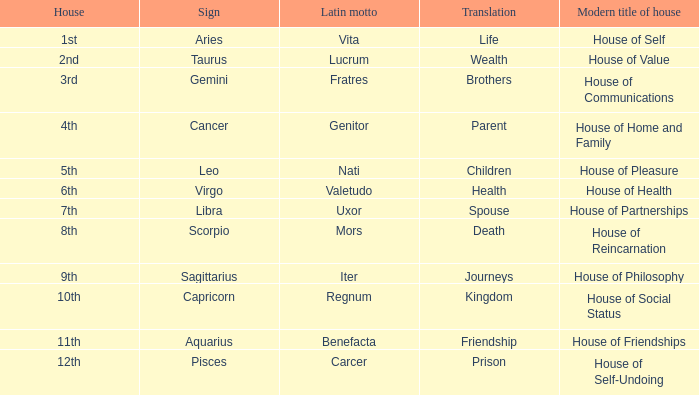What is the modern house title of the 1st house? House of Self. 